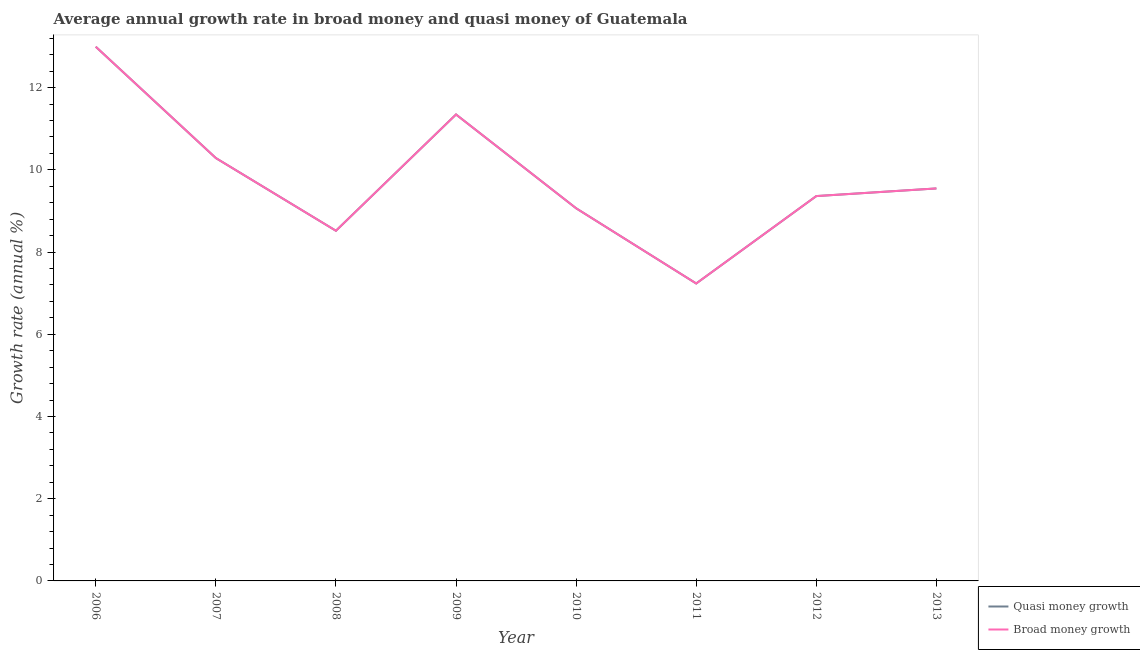Is the number of lines equal to the number of legend labels?
Ensure brevity in your answer.  Yes. What is the annual growth rate in quasi money in 2009?
Make the answer very short. 11.35. Across all years, what is the maximum annual growth rate in quasi money?
Offer a terse response. 12.99. Across all years, what is the minimum annual growth rate in quasi money?
Keep it short and to the point. 7.23. In which year was the annual growth rate in quasi money minimum?
Provide a short and direct response. 2011. What is the total annual growth rate in broad money in the graph?
Provide a succinct answer. 78.35. What is the difference between the annual growth rate in broad money in 2008 and that in 2010?
Your answer should be very brief. -0.55. What is the difference between the annual growth rate in broad money in 2012 and the annual growth rate in quasi money in 2010?
Your answer should be very brief. 0.3. What is the average annual growth rate in quasi money per year?
Ensure brevity in your answer.  9.79. In how many years, is the annual growth rate in quasi money greater than 12.4 %?
Provide a succinct answer. 1. What is the ratio of the annual growth rate in broad money in 2009 to that in 2010?
Provide a succinct answer. 1.25. Is the annual growth rate in quasi money in 2008 less than that in 2009?
Ensure brevity in your answer.  Yes. Is the difference between the annual growth rate in quasi money in 2008 and 2013 greater than the difference between the annual growth rate in broad money in 2008 and 2013?
Make the answer very short. No. What is the difference between the highest and the second highest annual growth rate in broad money?
Keep it short and to the point. 1.65. What is the difference between the highest and the lowest annual growth rate in quasi money?
Ensure brevity in your answer.  5.76. In how many years, is the annual growth rate in quasi money greater than the average annual growth rate in quasi money taken over all years?
Make the answer very short. 3. Is the sum of the annual growth rate in quasi money in 2006 and 2007 greater than the maximum annual growth rate in broad money across all years?
Provide a short and direct response. Yes. How many years are there in the graph?
Offer a very short reply. 8. What is the difference between two consecutive major ticks on the Y-axis?
Your answer should be compact. 2. Are the values on the major ticks of Y-axis written in scientific E-notation?
Your answer should be compact. No. Does the graph contain grids?
Provide a short and direct response. No. Where does the legend appear in the graph?
Give a very brief answer. Bottom right. How many legend labels are there?
Offer a very short reply. 2. How are the legend labels stacked?
Provide a succinct answer. Vertical. What is the title of the graph?
Your answer should be compact. Average annual growth rate in broad money and quasi money of Guatemala. What is the label or title of the X-axis?
Your response must be concise. Year. What is the label or title of the Y-axis?
Make the answer very short. Growth rate (annual %). What is the Growth rate (annual %) of Quasi money growth in 2006?
Make the answer very short. 12.99. What is the Growth rate (annual %) in Broad money growth in 2006?
Your answer should be very brief. 12.99. What is the Growth rate (annual %) of Quasi money growth in 2007?
Your response must be concise. 10.29. What is the Growth rate (annual %) in Broad money growth in 2007?
Provide a short and direct response. 10.29. What is the Growth rate (annual %) of Quasi money growth in 2008?
Make the answer very short. 8.52. What is the Growth rate (annual %) of Broad money growth in 2008?
Offer a terse response. 8.52. What is the Growth rate (annual %) of Quasi money growth in 2009?
Your answer should be very brief. 11.35. What is the Growth rate (annual %) in Broad money growth in 2009?
Ensure brevity in your answer.  11.35. What is the Growth rate (annual %) of Quasi money growth in 2010?
Your response must be concise. 9.06. What is the Growth rate (annual %) in Broad money growth in 2010?
Your answer should be very brief. 9.06. What is the Growth rate (annual %) of Quasi money growth in 2011?
Keep it short and to the point. 7.23. What is the Growth rate (annual %) in Broad money growth in 2011?
Offer a terse response. 7.23. What is the Growth rate (annual %) of Quasi money growth in 2012?
Your response must be concise. 9.36. What is the Growth rate (annual %) of Broad money growth in 2012?
Provide a short and direct response. 9.36. What is the Growth rate (annual %) of Quasi money growth in 2013?
Provide a short and direct response. 9.55. What is the Growth rate (annual %) in Broad money growth in 2013?
Provide a short and direct response. 9.55. Across all years, what is the maximum Growth rate (annual %) of Quasi money growth?
Ensure brevity in your answer.  12.99. Across all years, what is the maximum Growth rate (annual %) of Broad money growth?
Ensure brevity in your answer.  12.99. Across all years, what is the minimum Growth rate (annual %) of Quasi money growth?
Your answer should be compact. 7.23. Across all years, what is the minimum Growth rate (annual %) of Broad money growth?
Offer a terse response. 7.23. What is the total Growth rate (annual %) in Quasi money growth in the graph?
Your answer should be compact. 78.35. What is the total Growth rate (annual %) in Broad money growth in the graph?
Your answer should be very brief. 78.35. What is the difference between the Growth rate (annual %) of Quasi money growth in 2006 and that in 2007?
Offer a very short reply. 2.71. What is the difference between the Growth rate (annual %) of Broad money growth in 2006 and that in 2007?
Give a very brief answer. 2.71. What is the difference between the Growth rate (annual %) of Quasi money growth in 2006 and that in 2008?
Your answer should be compact. 4.48. What is the difference between the Growth rate (annual %) in Broad money growth in 2006 and that in 2008?
Give a very brief answer. 4.48. What is the difference between the Growth rate (annual %) of Quasi money growth in 2006 and that in 2009?
Provide a short and direct response. 1.65. What is the difference between the Growth rate (annual %) of Broad money growth in 2006 and that in 2009?
Give a very brief answer. 1.65. What is the difference between the Growth rate (annual %) in Quasi money growth in 2006 and that in 2010?
Your answer should be compact. 3.93. What is the difference between the Growth rate (annual %) in Broad money growth in 2006 and that in 2010?
Give a very brief answer. 3.93. What is the difference between the Growth rate (annual %) in Quasi money growth in 2006 and that in 2011?
Offer a terse response. 5.76. What is the difference between the Growth rate (annual %) of Broad money growth in 2006 and that in 2011?
Offer a very short reply. 5.76. What is the difference between the Growth rate (annual %) in Quasi money growth in 2006 and that in 2012?
Your response must be concise. 3.63. What is the difference between the Growth rate (annual %) in Broad money growth in 2006 and that in 2012?
Your answer should be very brief. 3.63. What is the difference between the Growth rate (annual %) of Quasi money growth in 2006 and that in 2013?
Your response must be concise. 3.45. What is the difference between the Growth rate (annual %) in Broad money growth in 2006 and that in 2013?
Offer a very short reply. 3.45. What is the difference between the Growth rate (annual %) in Quasi money growth in 2007 and that in 2008?
Keep it short and to the point. 1.77. What is the difference between the Growth rate (annual %) in Broad money growth in 2007 and that in 2008?
Make the answer very short. 1.77. What is the difference between the Growth rate (annual %) in Quasi money growth in 2007 and that in 2009?
Your response must be concise. -1.06. What is the difference between the Growth rate (annual %) in Broad money growth in 2007 and that in 2009?
Offer a very short reply. -1.06. What is the difference between the Growth rate (annual %) of Quasi money growth in 2007 and that in 2010?
Your answer should be very brief. 1.22. What is the difference between the Growth rate (annual %) in Broad money growth in 2007 and that in 2010?
Your answer should be very brief. 1.22. What is the difference between the Growth rate (annual %) in Quasi money growth in 2007 and that in 2011?
Your response must be concise. 3.05. What is the difference between the Growth rate (annual %) of Broad money growth in 2007 and that in 2011?
Ensure brevity in your answer.  3.05. What is the difference between the Growth rate (annual %) of Quasi money growth in 2007 and that in 2012?
Ensure brevity in your answer.  0.93. What is the difference between the Growth rate (annual %) in Broad money growth in 2007 and that in 2012?
Ensure brevity in your answer.  0.93. What is the difference between the Growth rate (annual %) in Quasi money growth in 2007 and that in 2013?
Keep it short and to the point. 0.74. What is the difference between the Growth rate (annual %) in Broad money growth in 2007 and that in 2013?
Give a very brief answer. 0.74. What is the difference between the Growth rate (annual %) of Quasi money growth in 2008 and that in 2009?
Provide a succinct answer. -2.83. What is the difference between the Growth rate (annual %) in Broad money growth in 2008 and that in 2009?
Ensure brevity in your answer.  -2.83. What is the difference between the Growth rate (annual %) of Quasi money growth in 2008 and that in 2010?
Make the answer very short. -0.55. What is the difference between the Growth rate (annual %) in Broad money growth in 2008 and that in 2010?
Your response must be concise. -0.55. What is the difference between the Growth rate (annual %) in Quasi money growth in 2008 and that in 2011?
Your answer should be very brief. 1.28. What is the difference between the Growth rate (annual %) of Broad money growth in 2008 and that in 2011?
Provide a short and direct response. 1.28. What is the difference between the Growth rate (annual %) in Quasi money growth in 2008 and that in 2012?
Offer a very short reply. -0.84. What is the difference between the Growth rate (annual %) in Broad money growth in 2008 and that in 2012?
Offer a very short reply. -0.84. What is the difference between the Growth rate (annual %) in Quasi money growth in 2008 and that in 2013?
Ensure brevity in your answer.  -1.03. What is the difference between the Growth rate (annual %) of Broad money growth in 2008 and that in 2013?
Offer a very short reply. -1.03. What is the difference between the Growth rate (annual %) of Quasi money growth in 2009 and that in 2010?
Offer a terse response. 2.28. What is the difference between the Growth rate (annual %) of Broad money growth in 2009 and that in 2010?
Provide a succinct answer. 2.28. What is the difference between the Growth rate (annual %) in Quasi money growth in 2009 and that in 2011?
Provide a short and direct response. 4.11. What is the difference between the Growth rate (annual %) of Broad money growth in 2009 and that in 2011?
Make the answer very short. 4.11. What is the difference between the Growth rate (annual %) in Quasi money growth in 2009 and that in 2012?
Give a very brief answer. 1.99. What is the difference between the Growth rate (annual %) in Broad money growth in 2009 and that in 2012?
Provide a succinct answer. 1.99. What is the difference between the Growth rate (annual %) in Quasi money growth in 2009 and that in 2013?
Keep it short and to the point. 1.8. What is the difference between the Growth rate (annual %) in Broad money growth in 2009 and that in 2013?
Give a very brief answer. 1.8. What is the difference between the Growth rate (annual %) of Quasi money growth in 2010 and that in 2011?
Keep it short and to the point. 1.83. What is the difference between the Growth rate (annual %) of Broad money growth in 2010 and that in 2011?
Offer a terse response. 1.83. What is the difference between the Growth rate (annual %) in Quasi money growth in 2010 and that in 2012?
Ensure brevity in your answer.  -0.3. What is the difference between the Growth rate (annual %) in Broad money growth in 2010 and that in 2012?
Provide a short and direct response. -0.3. What is the difference between the Growth rate (annual %) in Quasi money growth in 2010 and that in 2013?
Ensure brevity in your answer.  -0.48. What is the difference between the Growth rate (annual %) in Broad money growth in 2010 and that in 2013?
Give a very brief answer. -0.48. What is the difference between the Growth rate (annual %) in Quasi money growth in 2011 and that in 2012?
Offer a terse response. -2.13. What is the difference between the Growth rate (annual %) of Broad money growth in 2011 and that in 2012?
Provide a short and direct response. -2.13. What is the difference between the Growth rate (annual %) in Quasi money growth in 2011 and that in 2013?
Keep it short and to the point. -2.31. What is the difference between the Growth rate (annual %) of Broad money growth in 2011 and that in 2013?
Give a very brief answer. -2.31. What is the difference between the Growth rate (annual %) in Quasi money growth in 2012 and that in 2013?
Ensure brevity in your answer.  -0.19. What is the difference between the Growth rate (annual %) in Broad money growth in 2012 and that in 2013?
Provide a short and direct response. -0.19. What is the difference between the Growth rate (annual %) in Quasi money growth in 2006 and the Growth rate (annual %) in Broad money growth in 2007?
Offer a terse response. 2.71. What is the difference between the Growth rate (annual %) in Quasi money growth in 2006 and the Growth rate (annual %) in Broad money growth in 2008?
Provide a succinct answer. 4.48. What is the difference between the Growth rate (annual %) in Quasi money growth in 2006 and the Growth rate (annual %) in Broad money growth in 2009?
Offer a terse response. 1.65. What is the difference between the Growth rate (annual %) of Quasi money growth in 2006 and the Growth rate (annual %) of Broad money growth in 2010?
Make the answer very short. 3.93. What is the difference between the Growth rate (annual %) in Quasi money growth in 2006 and the Growth rate (annual %) in Broad money growth in 2011?
Give a very brief answer. 5.76. What is the difference between the Growth rate (annual %) of Quasi money growth in 2006 and the Growth rate (annual %) of Broad money growth in 2012?
Ensure brevity in your answer.  3.63. What is the difference between the Growth rate (annual %) of Quasi money growth in 2006 and the Growth rate (annual %) of Broad money growth in 2013?
Your answer should be compact. 3.45. What is the difference between the Growth rate (annual %) of Quasi money growth in 2007 and the Growth rate (annual %) of Broad money growth in 2008?
Keep it short and to the point. 1.77. What is the difference between the Growth rate (annual %) in Quasi money growth in 2007 and the Growth rate (annual %) in Broad money growth in 2009?
Your answer should be very brief. -1.06. What is the difference between the Growth rate (annual %) of Quasi money growth in 2007 and the Growth rate (annual %) of Broad money growth in 2010?
Your answer should be very brief. 1.22. What is the difference between the Growth rate (annual %) in Quasi money growth in 2007 and the Growth rate (annual %) in Broad money growth in 2011?
Ensure brevity in your answer.  3.05. What is the difference between the Growth rate (annual %) of Quasi money growth in 2007 and the Growth rate (annual %) of Broad money growth in 2012?
Make the answer very short. 0.93. What is the difference between the Growth rate (annual %) of Quasi money growth in 2007 and the Growth rate (annual %) of Broad money growth in 2013?
Keep it short and to the point. 0.74. What is the difference between the Growth rate (annual %) of Quasi money growth in 2008 and the Growth rate (annual %) of Broad money growth in 2009?
Offer a terse response. -2.83. What is the difference between the Growth rate (annual %) of Quasi money growth in 2008 and the Growth rate (annual %) of Broad money growth in 2010?
Your answer should be compact. -0.55. What is the difference between the Growth rate (annual %) of Quasi money growth in 2008 and the Growth rate (annual %) of Broad money growth in 2011?
Your answer should be compact. 1.28. What is the difference between the Growth rate (annual %) of Quasi money growth in 2008 and the Growth rate (annual %) of Broad money growth in 2012?
Keep it short and to the point. -0.84. What is the difference between the Growth rate (annual %) of Quasi money growth in 2008 and the Growth rate (annual %) of Broad money growth in 2013?
Provide a short and direct response. -1.03. What is the difference between the Growth rate (annual %) of Quasi money growth in 2009 and the Growth rate (annual %) of Broad money growth in 2010?
Provide a succinct answer. 2.28. What is the difference between the Growth rate (annual %) of Quasi money growth in 2009 and the Growth rate (annual %) of Broad money growth in 2011?
Make the answer very short. 4.11. What is the difference between the Growth rate (annual %) in Quasi money growth in 2009 and the Growth rate (annual %) in Broad money growth in 2012?
Provide a short and direct response. 1.99. What is the difference between the Growth rate (annual %) in Quasi money growth in 2009 and the Growth rate (annual %) in Broad money growth in 2013?
Ensure brevity in your answer.  1.8. What is the difference between the Growth rate (annual %) in Quasi money growth in 2010 and the Growth rate (annual %) in Broad money growth in 2011?
Provide a succinct answer. 1.83. What is the difference between the Growth rate (annual %) in Quasi money growth in 2010 and the Growth rate (annual %) in Broad money growth in 2012?
Offer a terse response. -0.3. What is the difference between the Growth rate (annual %) of Quasi money growth in 2010 and the Growth rate (annual %) of Broad money growth in 2013?
Your answer should be compact. -0.48. What is the difference between the Growth rate (annual %) of Quasi money growth in 2011 and the Growth rate (annual %) of Broad money growth in 2012?
Provide a succinct answer. -2.13. What is the difference between the Growth rate (annual %) of Quasi money growth in 2011 and the Growth rate (annual %) of Broad money growth in 2013?
Offer a terse response. -2.31. What is the difference between the Growth rate (annual %) in Quasi money growth in 2012 and the Growth rate (annual %) in Broad money growth in 2013?
Give a very brief answer. -0.19. What is the average Growth rate (annual %) in Quasi money growth per year?
Give a very brief answer. 9.79. What is the average Growth rate (annual %) of Broad money growth per year?
Ensure brevity in your answer.  9.79. In the year 2006, what is the difference between the Growth rate (annual %) of Quasi money growth and Growth rate (annual %) of Broad money growth?
Give a very brief answer. 0. In the year 2007, what is the difference between the Growth rate (annual %) of Quasi money growth and Growth rate (annual %) of Broad money growth?
Provide a succinct answer. 0. In the year 2009, what is the difference between the Growth rate (annual %) in Quasi money growth and Growth rate (annual %) in Broad money growth?
Your response must be concise. 0. In the year 2010, what is the difference between the Growth rate (annual %) of Quasi money growth and Growth rate (annual %) of Broad money growth?
Keep it short and to the point. 0. In the year 2011, what is the difference between the Growth rate (annual %) of Quasi money growth and Growth rate (annual %) of Broad money growth?
Your response must be concise. 0. What is the ratio of the Growth rate (annual %) in Quasi money growth in 2006 to that in 2007?
Make the answer very short. 1.26. What is the ratio of the Growth rate (annual %) in Broad money growth in 2006 to that in 2007?
Your answer should be very brief. 1.26. What is the ratio of the Growth rate (annual %) of Quasi money growth in 2006 to that in 2008?
Provide a succinct answer. 1.53. What is the ratio of the Growth rate (annual %) in Broad money growth in 2006 to that in 2008?
Your answer should be compact. 1.53. What is the ratio of the Growth rate (annual %) of Quasi money growth in 2006 to that in 2009?
Your answer should be compact. 1.15. What is the ratio of the Growth rate (annual %) in Broad money growth in 2006 to that in 2009?
Make the answer very short. 1.15. What is the ratio of the Growth rate (annual %) in Quasi money growth in 2006 to that in 2010?
Provide a short and direct response. 1.43. What is the ratio of the Growth rate (annual %) in Broad money growth in 2006 to that in 2010?
Your answer should be compact. 1.43. What is the ratio of the Growth rate (annual %) in Quasi money growth in 2006 to that in 2011?
Your answer should be very brief. 1.8. What is the ratio of the Growth rate (annual %) of Broad money growth in 2006 to that in 2011?
Offer a very short reply. 1.8. What is the ratio of the Growth rate (annual %) in Quasi money growth in 2006 to that in 2012?
Ensure brevity in your answer.  1.39. What is the ratio of the Growth rate (annual %) in Broad money growth in 2006 to that in 2012?
Your answer should be very brief. 1.39. What is the ratio of the Growth rate (annual %) of Quasi money growth in 2006 to that in 2013?
Offer a terse response. 1.36. What is the ratio of the Growth rate (annual %) of Broad money growth in 2006 to that in 2013?
Provide a short and direct response. 1.36. What is the ratio of the Growth rate (annual %) of Quasi money growth in 2007 to that in 2008?
Provide a succinct answer. 1.21. What is the ratio of the Growth rate (annual %) in Broad money growth in 2007 to that in 2008?
Your answer should be very brief. 1.21. What is the ratio of the Growth rate (annual %) in Quasi money growth in 2007 to that in 2009?
Your response must be concise. 0.91. What is the ratio of the Growth rate (annual %) of Broad money growth in 2007 to that in 2009?
Your answer should be very brief. 0.91. What is the ratio of the Growth rate (annual %) of Quasi money growth in 2007 to that in 2010?
Keep it short and to the point. 1.13. What is the ratio of the Growth rate (annual %) in Broad money growth in 2007 to that in 2010?
Offer a terse response. 1.13. What is the ratio of the Growth rate (annual %) of Quasi money growth in 2007 to that in 2011?
Ensure brevity in your answer.  1.42. What is the ratio of the Growth rate (annual %) of Broad money growth in 2007 to that in 2011?
Give a very brief answer. 1.42. What is the ratio of the Growth rate (annual %) in Quasi money growth in 2007 to that in 2012?
Provide a short and direct response. 1.1. What is the ratio of the Growth rate (annual %) of Broad money growth in 2007 to that in 2012?
Give a very brief answer. 1.1. What is the ratio of the Growth rate (annual %) in Quasi money growth in 2007 to that in 2013?
Give a very brief answer. 1.08. What is the ratio of the Growth rate (annual %) in Broad money growth in 2007 to that in 2013?
Provide a short and direct response. 1.08. What is the ratio of the Growth rate (annual %) of Quasi money growth in 2008 to that in 2009?
Offer a very short reply. 0.75. What is the ratio of the Growth rate (annual %) in Broad money growth in 2008 to that in 2009?
Keep it short and to the point. 0.75. What is the ratio of the Growth rate (annual %) of Quasi money growth in 2008 to that in 2010?
Make the answer very short. 0.94. What is the ratio of the Growth rate (annual %) of Broad money growth in 2008 to that in 2010?
Make the answer very short. 0.94. What is the ratio of the Growth rate (annual %) of Quasi money growth in 2008 to that in 2011?
Give a very brief answer. 1.18. What is the ratio of the Growth rate (annual %) of Broad money growth in 2008 to that in 2011?
Your response must be concise. 1.18. What is the ratio of the Growth rate (annual %) of Quasi money growth in 2008 to that in 2012?
Ensure brevity in your answer.  0.91. What is the ratio of the Growth rate (annual %) of Broad money growth in 2008 to that in 2012?
Provide a short and direct response. 0.91. What is the ratio of the Growth rate (annual %) of Quasi money growth in 2008 to that in 2013?
Your answer should be compact. 0.89. What is the ratio of the Growth rate (annual %) in Broad money growth in 2008 to that in 2013?
Give a very brief answer. 0.89. What is the ratio of the Growth rate (annual %) in Quasi money growth in 2009 to that in 2010?
Your answer should be compact. 1.25. What is the ratio of the Growth rate (annual %) in Broad money growth in 2009 to that in 2010?
Ensure brevity in your answer.  1.25. What is the ratio of the Growth rate (annual %) in Quasi money growth in 2009 to that in 2011?
Your answer should be compact. 1.57. What is the ratio of the Growth rate (annual %) of Broad money growth in 2009 to that in 2011?
Make the answer very short. 1.57. What is the ratio of the Growth rate (annual %) in Quasi money growth in 2009 to that in 2012?
Make the answer very short. 1.21. What is the ratio of the Growth rate (annual %) in Broad money growth in 2009 to that in 2012?
Make the answer very short. 1.21. What is the ratio of the Growth rate (annual %) in Quasi money growth in 2009 to that in 2013?
Offer a very short reply. 1.19. What is the ratio of the Growth rate (annual %) of Broad money growth in 2009 to that in 2013?
Make the answer very short. 1.19. What is the ratio of the Growth rate (annual %) of Quasi money growth in 2010 to that in 2011?
Your answer should be compact. 1.25. What is the ratio of the Growth rate (annual %) of Broad money growth in 2010 to that in 2011?
Ensure brevity in your answer.  1.25. What is the ratio of the Growth rate (annual %) in Quasi money growth in 2010 to that in 2012?
Give a very brief answer. 0.97. What is the ratio of the Growth rate (annual %) of Broad money growth in 2010 to that in 2012?
Offer a terse response. 0.97. What is the ratio of the Growth rate (annual %) of Quasi money growth in 2010 to that in 2013?
Provide a succinct answer. 0.95. What is the ratio of the Growth rate (annual %) of Broad money growth in 2010 to that in 2013?
Ensure brevity in your answer.  0.95. What is the ratio of the Growth rate (annual %) of Quasi money growth in 2011 to that in 2012?
Your answer should be very brief. 0.77. What is the ratio of the Growth rate (annual %) in Broad money growth in 2011 to that in 2012?
Ensure brevity in your answer.  0.77. What is the ratio of the Growth rate (annual %) of Quasi money growth in 2011 to that in 2013?
Keep it short and to the point. 0.76. What is the ratio of the Growth rate (annual %) in Broad money growth in 2011 to that in 2013?
Provide a succinct answer. 0.76. What is the ratio of the Growth rate (annual %) of Quasi money growth in 2012 to that in 2013?
Keep it short and to the point. 0.98. What is the ratio of the Growth rate (annual %) in Broad money growth in 2012 to that in 2013?
Provide a succinct answer. 0.98. What is the difference between the highest and the second highest Growth rate (annual %) in Quasi money growth?
Your answer should be very brief. 1.65. What is the difference between the highest and the second highest Growth rate (annual %) in Broad money growth?
Offer a terse response. 1.65. What is the difference between the highest and the lowest Growth rate (annual %) of Quasi money growth?
Make the answer very short. 5.76. What is the difference between the highest and the lowest Growth rate (annual %) in Broad money growth?
Offer a very short reply. 5.76. 